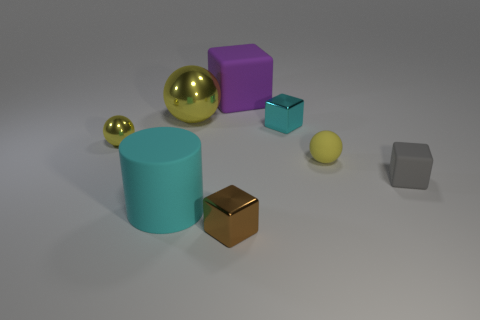How many other things are there of the same color as the big block?
Your response must be concise. 0. There is a small yellow object on the right side of the big block; what shape is it?
Your answer should be compact. Sphere. There is a yellow thing that is made of the same material as the cyan cylinder; what shape is it?
Give a very brief answer. Sphere. How many rubber objects are purple cylinders or big yellow spheres?
Your response must be concise. 0. What number of yellow things are on the right side of the rubber object in front of the matte block to the right of the big purple matte object?
Offer a terse response. 2. Is the size of the yellow object that is to the right of the large rubber block the same as the cyan object that is in front of the small gray rubber block?
Keep it short and to the point. No. There is a tiny cyan thing that is the same shape as the big purple object; what material is it?
Your answer should be very brief. Metal. How many tiny things are either spheres or brown cylinders?
Offer a terse response. 2. What is the material of the big ball?
Keep it short and to the point. Metal. What material is the block that is both to the left of the rubber ball and right of the big purple cube?
Keep it short and to the point. Metal. 